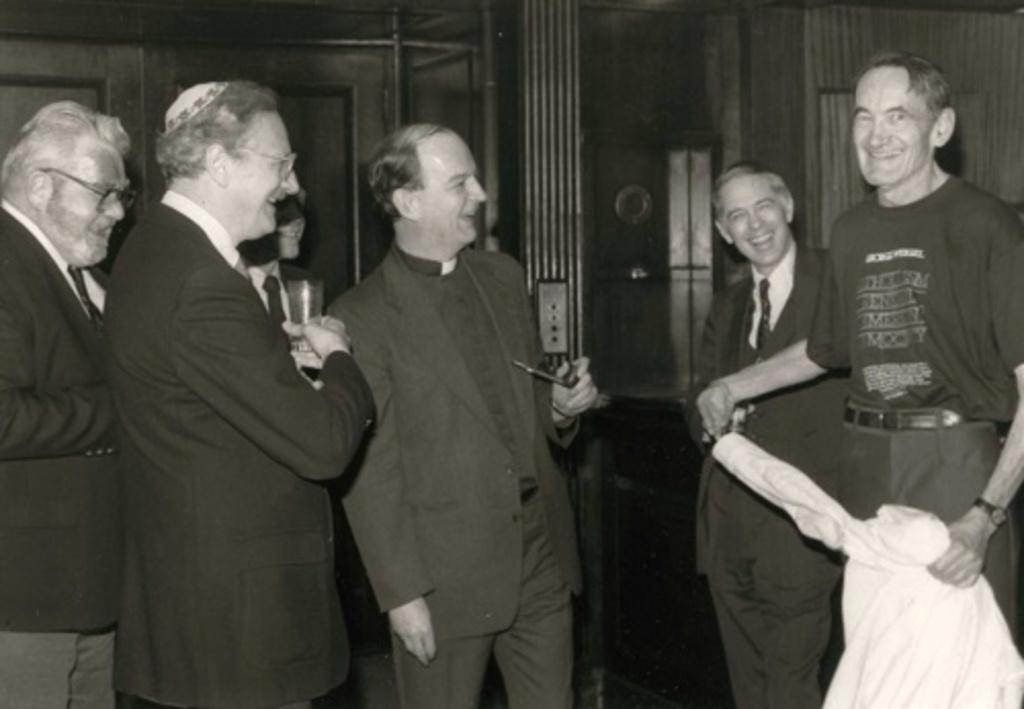Can you describe this image briefly? In this image I can see group of people standing. In front the person is holding a glass, background I can see few other people standing and the image is in black and white. 